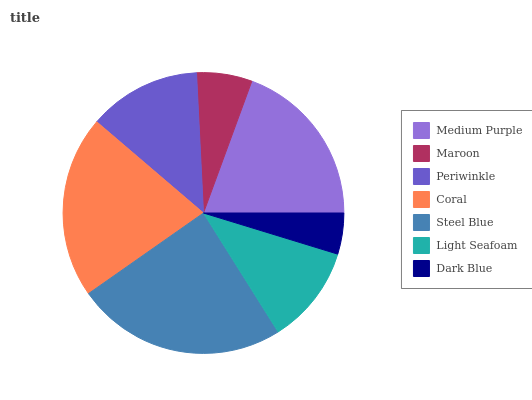Is Dark Blue the minimum?
Answer yes or no. Yes. Is Steel Blue the maximum?
Answer yes or no. Yes. Is Maroon the minimum?
Answer yes or no. No. Is Maroon the maximum?
Answer yes or no. No. Is Medium Purple greater than Maroon?
Answer yes or no. Yes. Is Maroon less than Medium Purple?
Answer yes or no. Yes. Is Maroon greater than Medium Purple?
Answer yes or no. No. Is Medium Purple less than Maroon?
Answer yes or no. No. Is Periwinkle the high median?
Answer yes or no. Yes. Is Periwinkle the low median?
Answer yes or no. Yes. Is Coral the high median?
Answer yes or no. No. Is Light Seafoam the low median?
Answer yes or no. No. 